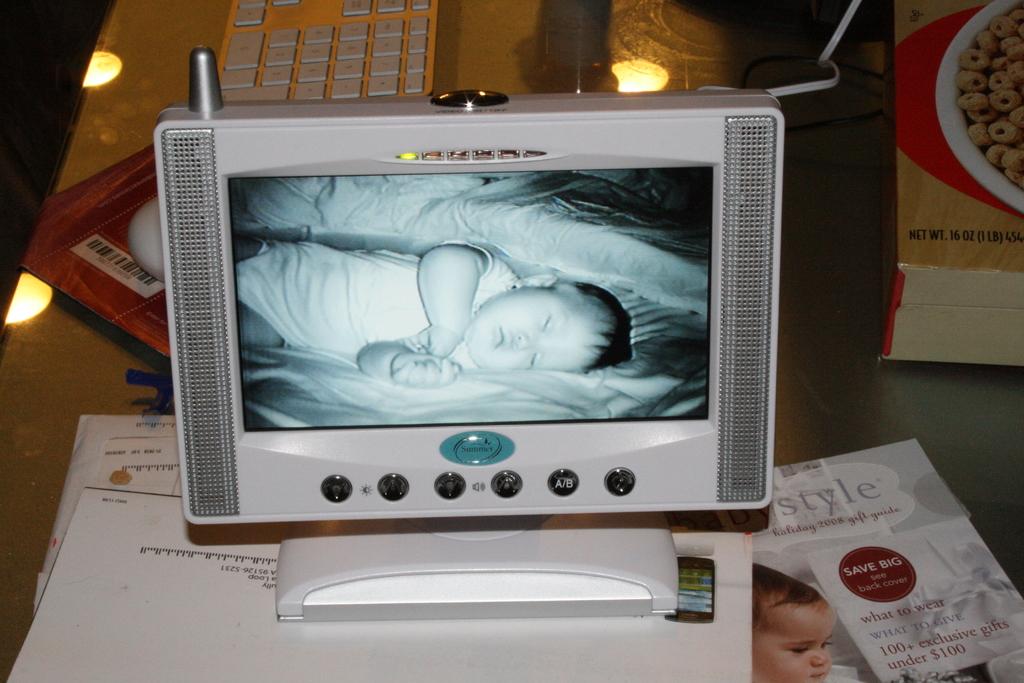What is written on the red sticker near the bottom?
Your answer should be very brief. Save big. 